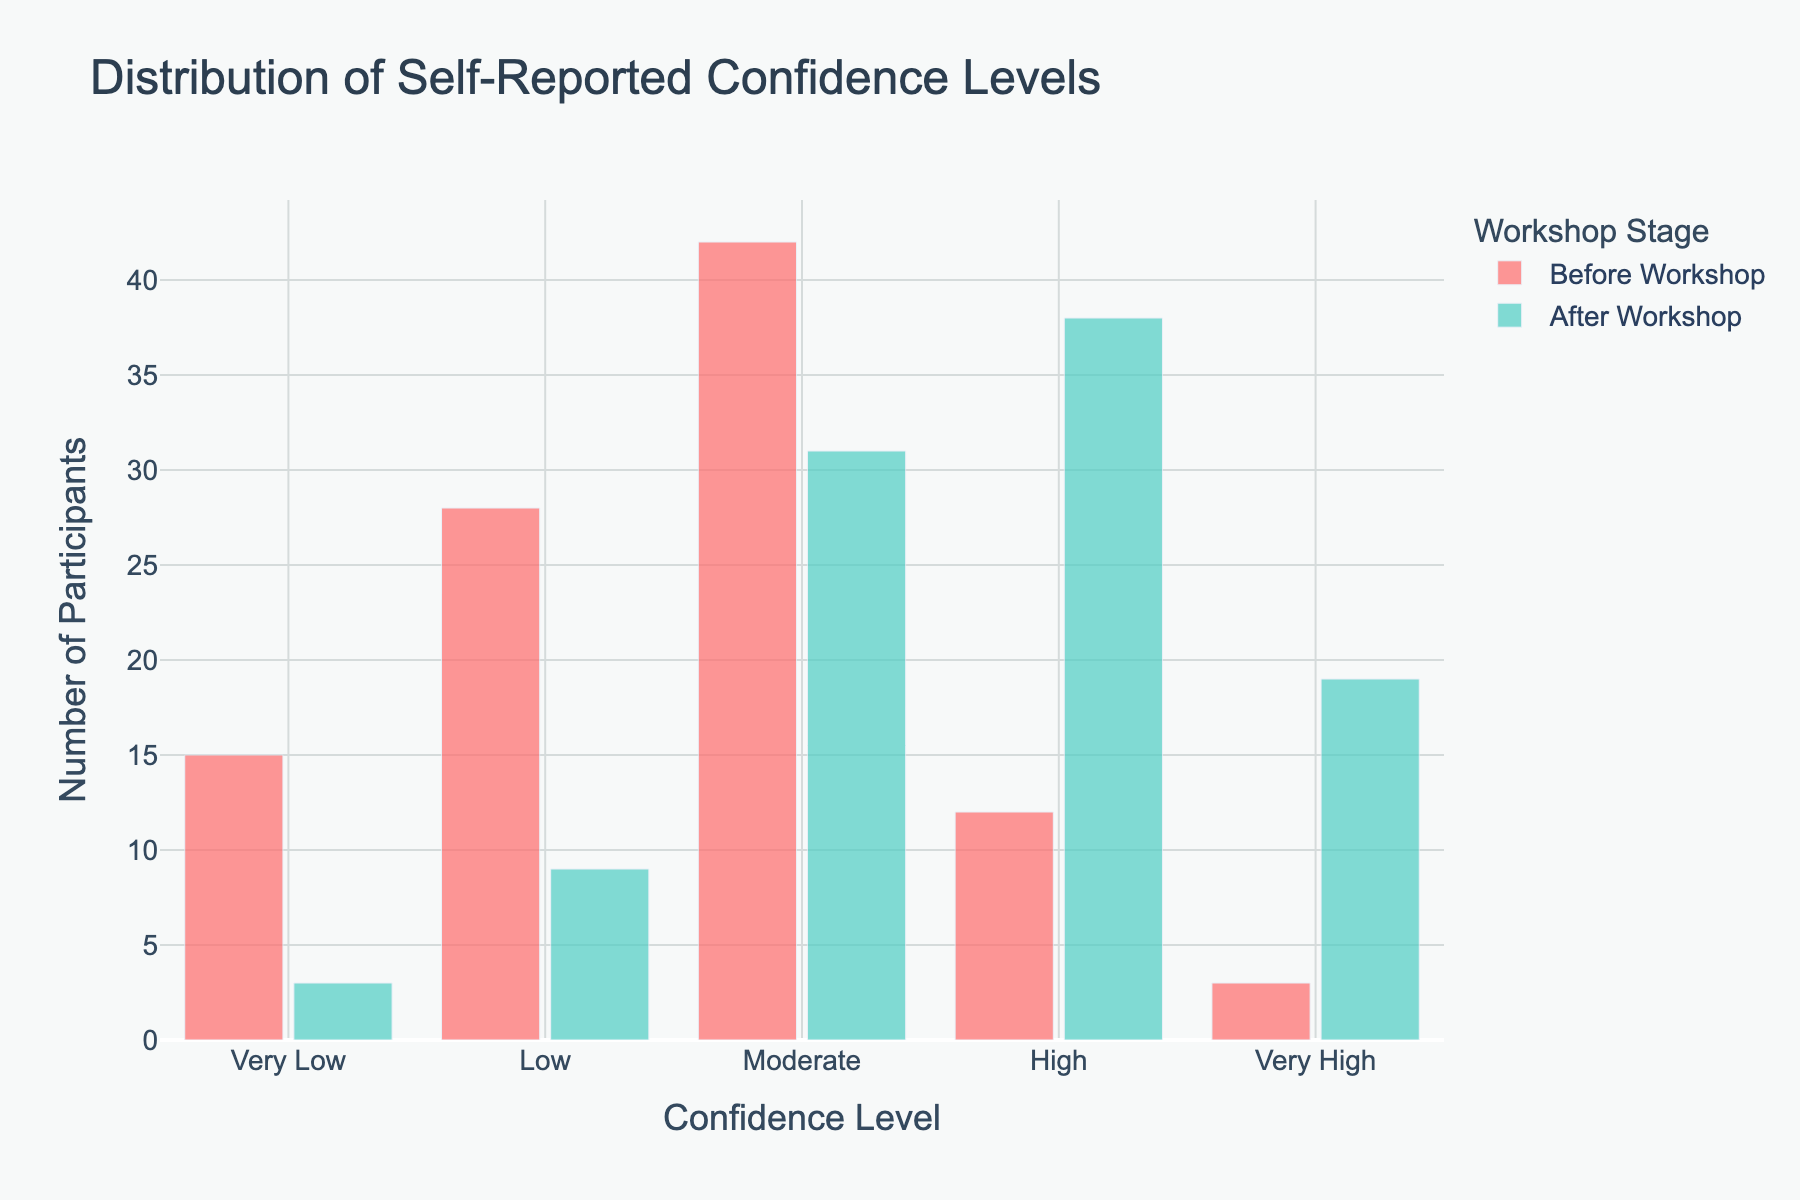What is the title of the histogram? The title is usually placed prominently at the top of the figure. It provides a brief description of the data being visualized. By referring to the top of the figure, we can see the title.
Answer: Distribution of Self-Reported Confidence Levels What does the x-axis represent? The x-axis is labeled at the bottom of the figure and often describes what categories or ranges are being plotted horizontally. Here, it shows the different levels of confidence.
Answer: Confidence Level How many participants reported "Very High" confidence after the workshop? By looking at the bar corresponding to "Very High" confidence on the x-axis and checking its height labeled "After Workshop," we can find the number of participants.
Answer: 19 How did the number of participants with "Moderate" confidence change from before to after the workshop? To find the change, refer to the height of the bars for "Moderate" confidence before and after the workshop and calculate the difference. Before: 42, After: 31. 42 - 31 = 11.
Answer: Decreased by 11 Which confidence level had the most significant increase in the number of participants after the workshop? Compare the height differences between the bars for each confidence level before and after the workshop. The largest difference will indicate the most significant increase. "High" confidence: Before: 12, After: 38. Increase = 38 - 12 = 26.
Answer: High What is the color of the bars representing "Before Workshop"? Colors are visually distinguishable and often indicated in the legend of the figure. By referring to the legend or observing the bar color, we can see the color for "Before Workshop."
Answer: Red Which confidence level had the fewest participants before the workshop? Identify the shortest bar labeled "Before Workshop" under the x-axis categories. The shortest bar indicates the fewest participants.
Answer: Very High Compare the total number of participants with "Low" and "High" confidence levels after the workshop. Which is greater? Refer to the heights of the bars labeled "After Workshop" for "Low" and "High" confidence levels and compare the numbers. Low: 9, High: 38.
Answer: High What is the bar gap and group gap for the bars in this histogram? The gap between bars within a group and the gap between different groups are usually fixed. The legend or plot settings often give these details.
Answer: 0.15 (bar gap) and 0.1 (group gap) Summarize the overall trend of confidence levels before and after the workshop. Observing the heights of the bars, we see that participants generally moved from lower to higher confidence levels after the workshop.
Answer: Increased confidence levels 